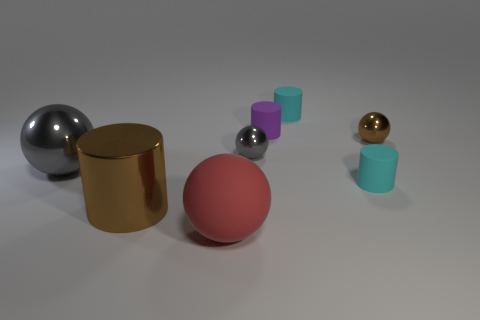Add 1 metallic spheres. How many objects exist? 9 Subtract all big red balls. How many balls are left? 3 Subtract all brown balls. How many balls are left? 3 Add 4 cyan matte cylinders. How many cyan matte cylinders are left? 6 Add 1 brown metal cylinders. How many brown metal cylinders exist? 2 Subtract 0 cyan blocks. How many objects are left? 8 Subtract 4 balls. How many balls are left? 0 Subtract all brown cylinders. Subtract all blue balls. How many cylinders are left? 3 Subtract all green spheres. How many cyan cylinders are left? 2 Subtract all small cylinders. Subtract all small purple things. How many objects are left? 4 